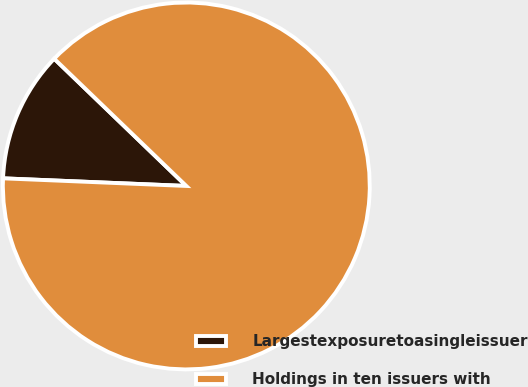Convert chart. <chart><loc_0><loc_0><loc_500><loc_500><pie_chart><fcel>Largestexposuretoasingleissuer<fcel>Holdings in ten issuers with<nl><fcel>11.54%<fcel>88.46%<nl></chart> 